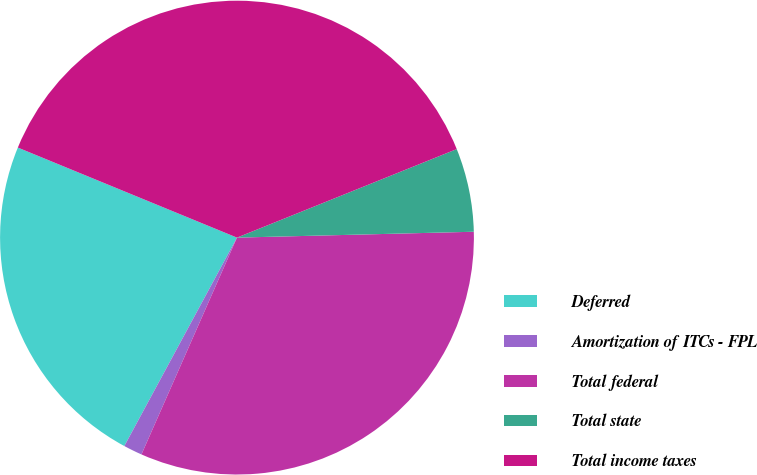Convert chart to OTSL. <chart><loc_0><loc_0><loc_500><loc_500><pie_chart><fcel>Deferred<fcel>Amortization of ITCs - FPL<fcel>Total federal<fcel>Total state<fcel>Total income taxes<nl><fcel>23.32%<fcel>1.28%<fcel>32.0%<fcel>5.7%<fcel>37.7%<nl></chart> 